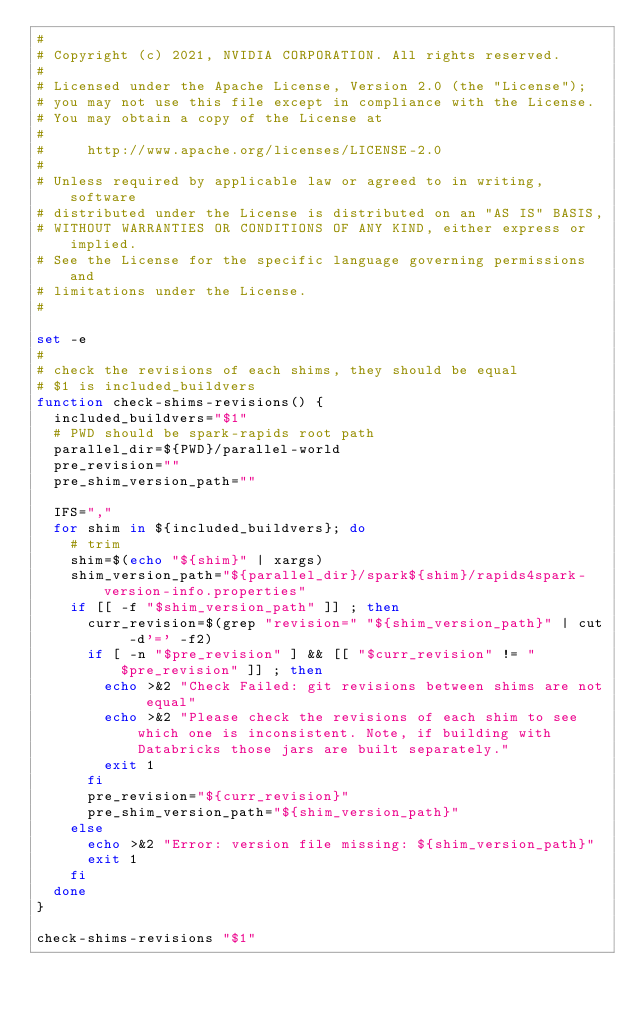Convert code to text. <code><loc_0><loc_0><loc_500><loc_500><_Bash_>#
# Copyright (c) 2021, NVIDIA CORPORATION. All rights reserved.
#
# Licensed under the Apache License, Version 2.0 (the "License");
# you may not use this file except in compliance with the License.
# You may obtain a copy of the License at
#
#     http://www.apache.org/licenses/LICENSE-2.0
#
# Unless required by applicable law or agreed to in writing, software
# distributed under the License is distributed on an "AS IS" BASIS,
# WITHOUT WARRANTIES OR CONDITIONS OF ANY KIND, either express or implied.
# See the License for the specific language governing permissions and
# limitations under the License.
#

set -e
#
# check the revisions of each shims, they should be equal
# $1 is included_buildvers
function check-shims-revisions() {
  included_buildvers="$1"
  # PWD should be spark-rapids root path
  parallel_dir=${PWD}/parallel-world
  pre_revision=""
  pre_shim_version_path=""

  IFS=","
  for shim in ${included_buildvers}; do
    # trim
    shim=$(echo "${shim}" | xargs)
    shim_version_path="${parallel_dir}/spark${shim}/rapids4spark-version-info.properties"
    if [[ -f "$shim_version_path" ]] ; then
      curr_revision=$(grep "revision=" "${shim_version_path}" | cut -d'=' -f2)
      if [ -n "$pre_revision" ] && [[ "$curr_revision" != "$pre_revision" ]] ; then
        echo >&2 "Check Failed: git revisions between shims are not equal"
        echo >&2 "Please check the revisions of each shim to see which one is inconsistent. Note, if building with Databricks those jars are built separately."
        exit 1
      fi
      pre_revision="${curr_revision}"
      pre_shim_version_path="${shim_version_path}"
    else
      echo >&2 "Error: version file missing: ${shim_version_path}"
      exit 1
    fi
  done
}

check-shims-revisions "$1"
</code> 